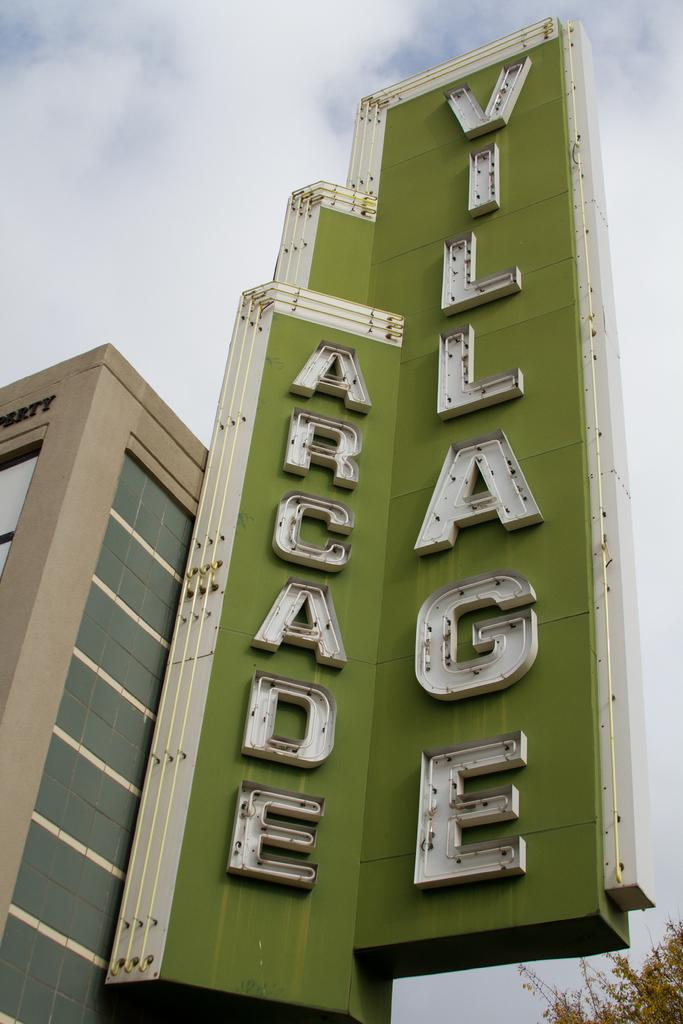What is the main structure visible in the picture? There is a building in the picture. Is there any text or signage near the building? Yes, there is a name written on a green background beside the building. How prominent is the name in the image? The name is very huge in the image. What can be seen in the background of the picture? The sky is visible in the background of the picture. How many birds are sitting on the underwear in the image? There are no birds or underwear present in the image. 